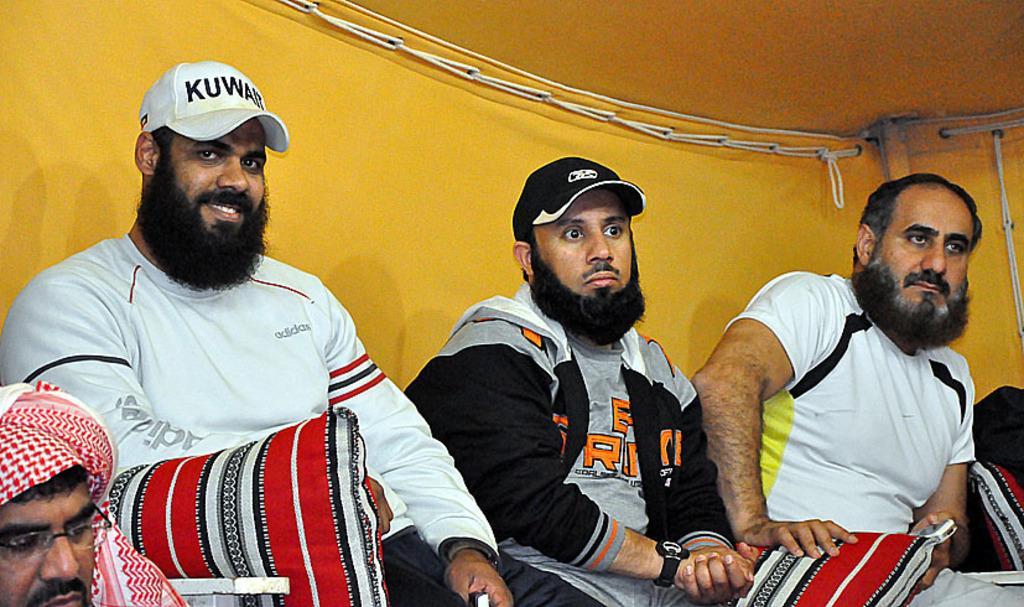Please provide a concise description of this image. In this image, there are a few people, pillows. We can see the yellow colored background with some objects. We can also see the roof. 